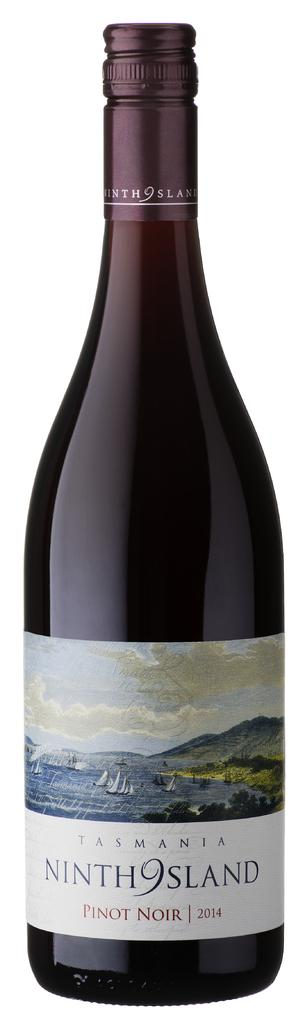Provide a one-sentence caption for the provided image. The 2014 Ninth Island Pinot Noir is made by Tasmadia. 